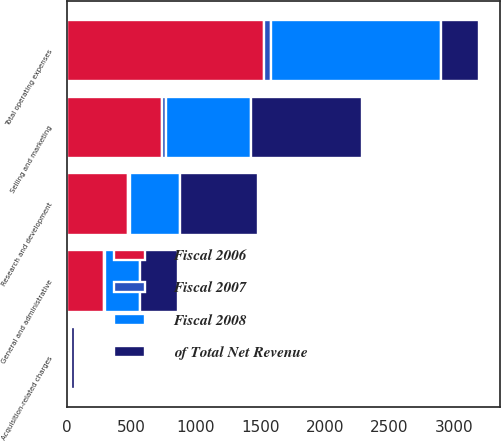Convert chart to OTSL. <chart><loc_0><loc_0><loc_500><loc_500><stacked_bar_chart><ecel><fcel>Selling and marketing<fcel>Research and development<fcel>General and administrative<fcel>Acquisition-related charges<fcel>Total operating expenses<nl><fcel>of Total Net Revenue<fcel>859.6<fcel>605.8<fcel>295<fcel>35.5<fcel>291.1<nl><fcel>Fiscal 2007<fcel>28<fcel>20<fcel>10<fcel>1<fcel>59<nl><fcel>Fiscal 2006<fcel>742.4<fcel>472.5<fcel>291.1<fcel>20<fcel>1526<nl><fcel>Fiscal 2008<fcel>657.6<fcel>385.8<fcel>267.2<fcel>9.5<fcel>1320.1<nl></chart> 